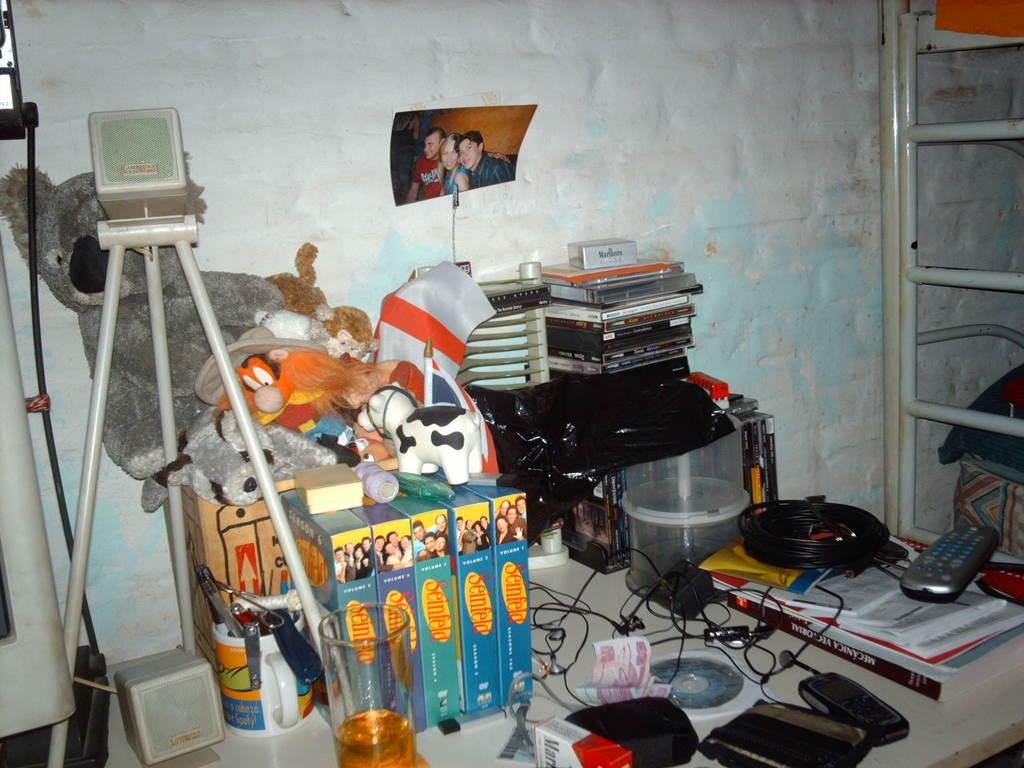What objects can be seen on the table in the image? There are books, a remote, earphones, cash, cups, a tripod, and toys on the table in the image. What activity might be related to the presence of the tripod on the table? Photography is mentioned in the context of the image, so the tripod might be used for photography. What is the location of the table in the image? The table is in front of a wall. What object can be seen on the right side of the image? There is a ladder on the right side of the image. Can you describe the hill in the background of the image? There is no hill present in the image; it features a table with various objects and a ladder on the right side. What type of ray is visible in the image? There is no ray present in the image. 